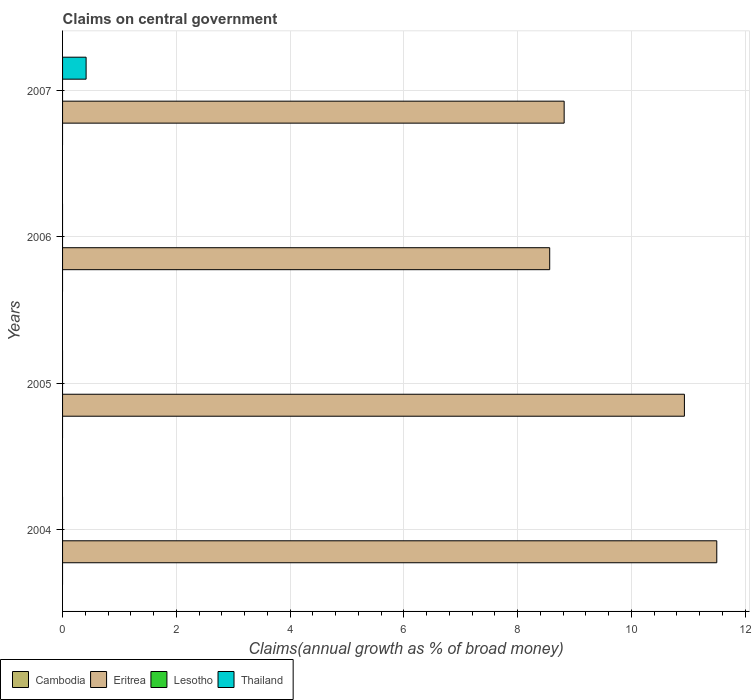Are the number of bars per tick equal to the number of legend labels?
Provide a short and direct response. No. Are the number of bars on each tick of the Y-axis equal?
Your answer should be very brief. No. How many bars are there on the 3rd tick from the top?
Offer a very short reply. 1. How many bars are there on the 1st tick from the bottom?
Make the answer very short. 1. In how many cases, is the number of bars for a given year not equal to the number of legend labels?
Ensure brevity in your answer.  4. Across all years, what is the maximum percentage of broad money claimed on centeral government in Thailand?
Make the answer very short. 0.41. Across all years, what is the minimum percentage of broad money claimed on centeral government in Thailand?
Give a very brief answer. 0. What is the total percentage of broad money claimed on centeral government in Thailand in the graph?
Your answer should be compact. 0.41. What is the difference between the percentage of broad money claimed on centeral government in Eritrea in 2004 and that in 2006?
Provide a short and direct response. 2.94. What is the difference between the percentage of broad money claimed on centeral government in Lesotho in 2005 and the percentage of broad money claimed on centeral government in Thailand in 2007?
Your response must be concise. -0.41. What is the average percentage of broad money claimed on centeral government in Eritrea per year?
Offer a terse response. 9.95. What is the ratio of the percentage of broad money claimed on centeral government in Eritrea in 2004 to that in 2006?
Offer a very short reply. 1.34. Is the percentage of broad money claimed on centeral government in Eritrea in 2005 less than that in 2007?
Give a very brief answer. No. What is the difference between the highest and the second highest percentage of broad money claimed on centeral government in Eritrea?
Ensure brevity in your answer.  0.57. What is the difference between the highest and the lowest percentage of broad money claimed on centeral government in Thailand?
Give a very brief answer. 0.41. Is the sum of the percentage of broad money claimed on centeral government in Eritrea in 2005 and 2007 greater than the maximum percentage of broad money claimed on centeral government in Thailand across all years?
Provide a succinct answer. Yes. Is it the case that in every year, the sum of the percentage of broad money claimed on centeral government in Lesotho and percentage of broad money claimed on centeral government in Eritrea is greater than the sum of percentage of broad money claimed on centeral government in Cambodia and percentage of broad money claimed on centeral government in Thailand?
Your response must be concise. Yes. Is it the case that in every year, the sum of the percentage of broad money claimed on centeral government in Eritrea and percentage of broad money claimed on centeral government in Lesotho is greater than the percentage of broad money claimed on centeral government in Thailand?
Provide a succinct answer. Yes. Are all the bars in the graph horizontal?
Keep it short and to the point. Yes. How many years are there in the graph?
Offer a very short reply. 4. Are the values on the major ticks of X-axis written in scientific E-notation?
Keep it short and to the point. No. Where does the legend appear in the graph?
Give a very brief answer. Bottom left. How many legend labels are there?
Your answer should be compact. 4. How are the legend labels stacked?
Provide a succinct answer. Horizontal. What is the title of the graph?
Ensure brevity in your answer.  Claims on central government. Does "Denmark" appear as one of the legend labels in the graph?
Make the answer very short. No. What is the label or title of the X-axis?
Provide a succinct answer. Claims(annual growth as % of broad money). What is the label or title of the Y-axis?
Give a very brief answer. Years. What is the Claims(annual growth as % of broad money) in Eritrea in 2004?
Make the answer very short. 11.5. What is the Claims(annual growth as % of broad money) of Lesotho in 2004?
Give a very brief answer. 0. What is the Claims(annual growth as % of broad money) of Thailand in 2004?
Keep it short and to the point. 0. What is the Claims(annual growth as % of broad money) in Cambodia in 2005?
Provide a short and direct response. 0. What is the Claims(annual growth as % of broad money) of Eritrea in 2005?
Give a very brief answer. 10.93. What is the Claims(annual growth as % of broad money) in Thailand in 2005?
Your answer should be compact. 0. What is the Claims(annual growth as % of broad money) of Cambodia in 2006?
Keep it short and to the point. 0. What is the Claims(annual growth as % of broad money) of Eritrea in 2006?
Your answer should be very brief. 8.56. What is the Claims(annual growth as % of broad money) of Lesotho in 2006?
Offer a very short reply. 0. What is the Claims(annual growth as % of broad money) of Thailand in 2006?
Your answer should be very brief. 0. What is the Claims(annual growth as % of broad money) in Cambodia in 2007?
Give a very brief answer. 0. What is the Claims(annual growth as % of broad money) of Eritrea in 2007?
Ensure brevity in your answer.  8.82. What is the Claims(annual growth as % of broad money) in Lesotho in 2007?
Your response must be concise. 0. What is the Claims(annual growth as % of broad money) of Thailand in 2007?
Give a very brief answer. 0.41. Across all years, what is the maximum Claims(annual growth as % of broad money) in Eritrea?
Make the answer very short. 11.5. Across all years, what is the maximum Claims(annual growth as % of broad money) of Thailand?
Keep it short and to the point. 0.41. Across all years, what is the minimum Claims(annual growth as % of broad money) of Eritrea?
Ensure brevity in your answer.  8.56. Across all years, what is the minimum Claims(annual growth as % of broad money) of Thailand?
Ensure brevity in your answer.  0. What is the total Claims(annual growth as % of broad money) of Eritrea in the graph?
Your answer should be very brief. 39.82. What is the total Claims(annual growth as % of broad money) in Thailand in the graph?
Ensure brevity in your answer.  0.41. What is the difference between the Claims(annual growth as % of broad money) of Eritrea in 2004 and that in 2005?
Your answer should be very brief. 0.57. What is the difference between the Claims(annual growth as % of broad money) in Eritrea in 2004 and that in 2006?
Your response must be concise. 2.94. What is the difference between the Claims(annual growth as % of broad money) in Eritrea in 2004 and that in 2007?
Your answer should be very brief. 2.68. What is the difference between the Claims(annual growth as % of broad money) in Eritrea in 2005 and that in 2006?
Your answer should be very brief. 2.37. What is the difference between the Claims(annual growth as % of broad money) in Eritrea in 2005 and that in 2007?
Give a very brief answer. 2.11. What is the difference between the Claims(annual growth as % of broad money) of Eritrea in 2006 and that in 2007?
Provide a succinct answer. -0.25. What is the difference between the Claims(annual growth as % of broad money) in Eritrea in 2004 and the Claims(annual growth as % of broad money) in Thailand in 2007?
Provide a short and direct response. 11.09. What is the difference between the Claims(annual growth as % of broad money) in Eritrea in 2005 and the Claims(annual growth as % of broad money) in Thailand in 2007?
Your response must be concise. 10.52. What is the difference between the Claims(annual growth as % of broad money) of Eritrea in 2006 and the Claims(annual growth as % of broad money) of Thailand in 2007?
Your answer should be very brief. 8.15. What is the average Claims(annual growth as % of broad money) in Cambodia per year?
Offer a terse response. 0. What is the average Claims(annual growth as % of broad money) of Eritrea per year?
Your response must be concise. 9.95. What is the average Claims(annual growth as % of broad money) in Thailand per year?
Provide a short and direct response. 0.1. In the year 2007, what is the difference between the Claims(annual growth as % of broad money) in Eritrea and Claims(annual growth as % of broad money) in Thailand?
Your answer should be very brief. 8.4. What is the ratio of the Claims(annual growth as % of broad money) in Eritrea in 2004 to that in 2005?
Keep it short and to the point. 1.05. What is the ratio of the Claims(annual growth as % of broad money) of Eritrea in 2004 to that in 2006?
Offer a terse response. 1.34. What is the ratio of the Claims(annual growth as % of broad money) of Eritrea in 2004 to that in 2007?
Ensure brevity in your answer.  1.3. What is the ratio of the Claims(annual growth as % of broad money) of Eritrea in 2005 to that in 2006?
Ensure brevity in your answer.  1.28. What is the ratio of the Claims(annual growth as % of broad money) of Eritrea in 2005 to that in 2007?
Your answer should be compact. 1.24. What is the ratio of the Claims(annual growth as % of broad money) in Eritrea in 2006 to that in 2007?
Your response must be concise. 0.97. What is the difference between the highest and the second highest Claims(annual growth as % of broad money) of Eritrea?
Provide a short and direct response. 0.57. What is the difference between the highest and the lowest Claims(annual growth as % of broad money) in Eritrea?
Ensure brevity in your answer.  2.94. What is the difference between the highest and the lowest Claims(annual growth as % of broad money) in Thailand?
Give a very brief answer. 0.41. 